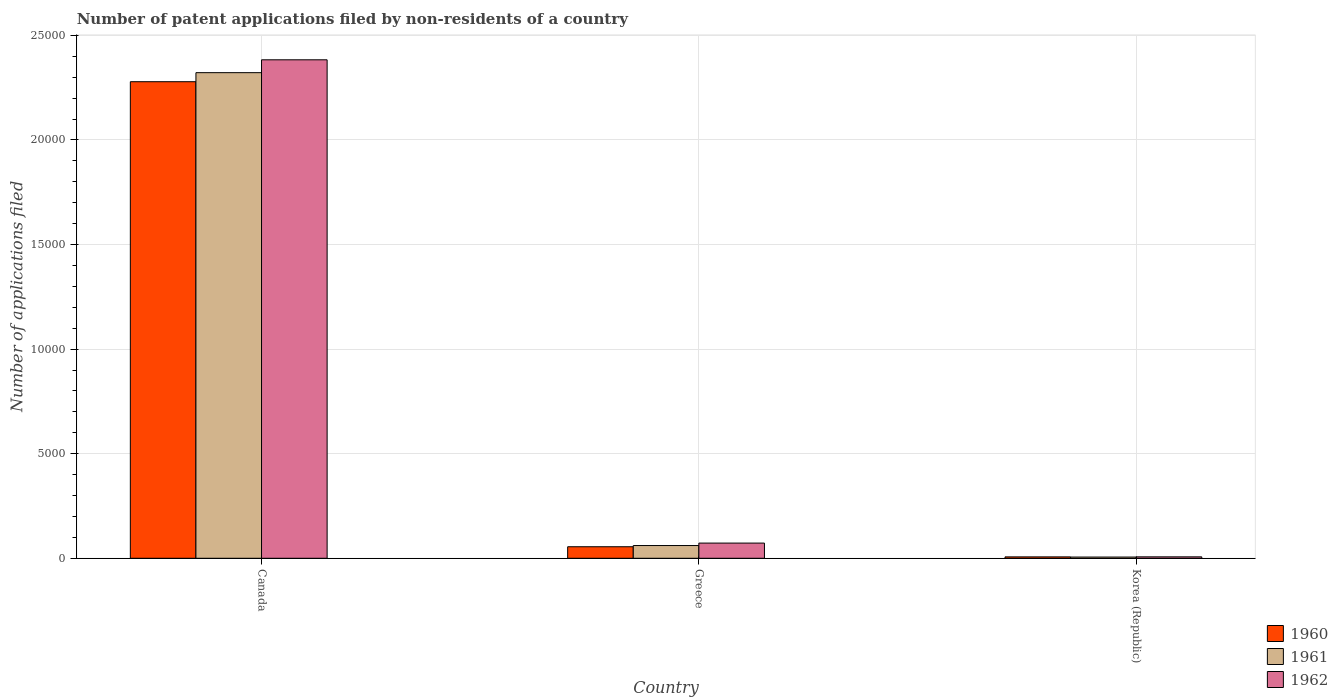Are the number of bars on each tick of the X-axis equal?
Provide a short and direct response. Yes. How many bars are there on the 1st tick from the left?
Your answer should be very brief. 3. What is the label of the 1st group of bars from the left?
Keep it short and to the point. Canada. What is the number of applications filed in 1960 in Canada?
Your response must be concise. 2.28e+04. Across all countries, what is the maximum number of applications filed in 1962?
Make the answer very short. 2.38e+04. In which country was the number of applications filed in 1961 maximum?
Give a very brief answer. Canada. In which country was the number of applications filed in 1961 minimum?
Ensure brevity in your answer.  Korea (Republic). What is the total number of applications filed in 1960 in the graph?
Provide a short and direct response. 2.34e+04. What is the difference between the number of applications filed in 1960 in Greece and that in Korea (Republic)?
Provide a succinct answer. 485. What is the difference between the number of applications filed in 1961 in Canada and the number of applications filed in 1962 in Greece?
Offer a terse response. 2.25e+04. What is the average number of applications filed in 1961 per country?
Your answer should be very brief. 7962. What is the difference between the number of applications filed of/in 1960 and number of applications filed of/in 1962 in Canada?
Your answer should be compact. -1048. In how many countries, is the number of applications filed in 1960 greater than 2000?
Provide a short and direct response. 1. What is the ratio of the number of applications filed in 1962 in Canada to that in Greece?
Your answer should be very brief. 32.83. Is the number of applications filed in 1962 in Canada less than that in Greece?
Offer a very short reply. No. Is the difference between the number of applications filed in 1960 in Greece and Korea (Republic) greater than the difference between the number of applications filed in 1962 in Greece and Korea (Republic)?
Your answer should be compact. No. What is the difference between the highest and the second highest number of applications filed in 1962?
Offer a very short reply. 2.38e+04. What is the difference between the highest and the lowest number of applications filed in 1960?
Offer a terse response. 2.27e+04. What does the 3rd bar from the right in Canada represents?
Keep it short and to the point. 1960. Are all the bars in the graph horizontal?
Provide a short and direct response. No. What is the difference between two consecutive major ticks on the Y-axis?
Your answer should be compact. 5000. Are the values on the major ticks of Y-axis written in scientific E-notation?
Offer a terse response. No. How many legend labels are there?
Provide a succinct answer. 3. What is the title of the graph?
Ensure brevity in your answer.  Number of patent applications filed by non-residents of a country. Does "1998" appear as one of the legend labels in the graph?
Your response must be concise. No. What is the label or title of the X-axis?
Ensure brevity in your answer.  Country. What is the label or title of the Y-axis?
Your answer should be very brief. Number of applications filed. What is the Number of applications filed of 1960 in Canada?
Your response must be concise. 2.28e+04. What is the Number of applications filed in 1961 in Canada?
Give a very brief answer. 2.32e+04. What is the Number of applications filed in 1962 in Canada?
Your answer should be compact. 2.38e+04. What is the Number of applications filed of 1960 in Greece?
Make the answer very short. 551. What is the Number of applications filed in 1961 in Greece?
Provide a short and direct response. 609. What is the Number of applications filed in 1962 in Greece?
Provide a short and direct response. 726. What is the Number of applications filed in 1960 in Korea (Republic)?
Keep it short and to the point. 66. What is the Number of applications filed in 1961 in Korea (Republic)?
Make the answer very short. 58. What is the Number of applications filed of 1962 in Korea (Republic)?
Your answer should be compact. 68. Across all countries, what is the maximum Number of applications filed of 1960?
Provide a short and direct response. 2.28e+04. Across all countries, what is the maximum Number of applications filed in 1961?
Your answer should be very brief. 2.32e+04. Across all countries, what is the maximum Number of applications filed in 1962?
Provide a succinct answer. 2.38e+04. Across all countries, what is the minimum Number of applications filed in 1960?
Keep it short and to the point. 66. Across all countries, what is the minimum Number of applications filed in 1962?
Make the answer very short. 68. What is the total Number of applications filed of 1960 in the graph?
Ensure brevity in your answer.  2.34e+04. What is the total Number of applications filed of 1961 in the graph?
Keep it short and to the point. 2.39e+04. What is the total Number of applications filed of 1962 in the graph?
Your answer should be compact. 2.46e+04. What is the difference between the Number of applications filed of 1960 in Canada and that in Greece?
Offer a very short reply. 2.22e+04. What is the difference between the Number of applications filed in 1961 in Canada and that in Greece?
Offer a very short reply. 2.26e+04. What is the difference between the Number of applications filed in 1962 in Canada and that in Greece?
Your response must be concise. 2.31e+04. What is the difference between the Number of applications filed of 1960 in Canada and that in Korea (Republic)?
Make the answer very short. 2.27e+04. What is the difference between the Number of applications filed of 1961 in Canada and that in Korea (Republic)?
Your answer should be very brief. 2.32e+04. What is the difference between the Number of applications filed of 1962 in Canada and that in Korea (Republic)?
Make the answer very short. 2.38e+04. What is the difference between the Number of applications filed in 1960 in Greece and that in Korea (Republic)?
Offer a very short reply. 485. What is the difference between the Number of applications filed in 1961 in Greece and that in Korea (Republic)?
Make the answer very short. 551. What is the difference between the Number of applications filed in 1962 in Greece and that in Korea (Republic)?
Ensure brevity in your answer.  658. What is the difference between the Number of applications filed of 1960 in Canada and the Number of applications filed of 1961 in Greece?
Offer a very short reply. 2.22e+04. What is the difference between the Number of applications filed in 1960 in Canada and the Number of applications filed in 1962 in Greece?
Make the answer very short. 2.21e+04. What is the difference between the Number of applications filed in 1961 in Canada and the Number of applications filed in 1962 in Greece?
Your answer should be compact. 2.25e+04. What is the difference between the Number of applications filed of 1960 in Canada and the Number of applications filed of 1961 in Korea (Republic)?
Provide a succinct answer. 2.27e+04. What is the difference between the Number of applications filed in 1960 in Canada and the Number of applications filed in 1962 in Korea (Republic)?
Offer a terse response. 2.27e+04. What is the difference between the Number of applications filed in 1961 in Canada and the Number of applications filed in 1962 in Korea (Republic)?
Your answer should be compact. 2.32e+04. What is the difference between the Number of applications filed in 1960 in Greece and the Number of applications filed in 1961 in Korea (Republic)?
Offer a terse response. 493. What is the difference between the Number of applications filed of 1960 in Greece and the Number of applications filed of 1962 in Korea (Republic)?
Your answer should be compact. 483. What is the difference between the Number of applications filed of 1961 in Greece and the Number of applications filed of 1962 in Korea (Republic)?
Make the answer very short. 541. What is the average Number of applications filed of 1960 per country?
Your answer should be very brief. 7801. What is the average Number of applications filed of 1961 per country?
Keep it short and to the point. 7962. What is the average Number of applications filed of 1962 per country?
Ensure brevity in your answer.  8209.33. What is the difference between the Number of applications filed in 1960 and Number of applications filed in 1961 in Canada?
Your response must be concise. -433. What is the difference between the Number of applications filed of 1960 and Number of applications filed of 1962 in Canada?
Offer a very short reply. -1048. What is the difference between the Number of applications filed of 1961 and Number of applications filed of 1962 in Canada?
Give a very brief answer. -615. What is the difference between the Number of applications filed in 1960 and Number of applications filed in 1961 in Greece?
Give a very brief answer. -58. What is the difference between the Number of applications filed of 1960 and Number of applications filed of 1962 in Greece?
Offer a very short reply. -175. What is the difference between the Number of applications filed in 1961 and Number of applications filed in 1962 in Greece?
Offer a terse response. -117. What is the difference between the Number of applications filed in 1960 and Number of applications filed in 1961 in Korea (Republic)?
Offer a terse response. 8. What is the difference between the Number of applications filed in 1961 and Number of applications filed in 1962 in Korea (Republic)?
Your answer should be compact. -10. What is the ratio of the Number of applications filed in 1960 in Canada to that in Greece?
Offer a very short reply. 41.35. What is the ratio of the Number of applications filed in 1961 in Canada to that in Greece?
Ensure brevity in your answer.  38.13. What is the ratio of the Number of applications filed of 1962 in Canada to that in Greece?
Give a very brief answer. 32.83. What is the ratio of the Number of applications filed of 1960 in Canada to that in Korea (Republic)?
Your answer should be very brief. 345.24. What is the ratio of the Number of applications filed in 1961 in Canada to that in Korea (Republic)?
Your answer should be compact. 400.33. What is the ratio of the Number of applications filed in 1962 in Canada to that in Korea (Republic)?
Provide a succinct answer. 350.5. What is the ratio of the Number of applications filed of 1960 in Greece to that in Korea (Republic)?
Provide a short and direct response. 8.35. What is the ratio of the Number of applications filed of 1962 in Greece to that in Korea (Republic)?
Offer a terse response. 10.68. What is the difference between the highest and the second highest Number of applications filed in 1960?
Ensure brevity in your answer.  2.22e+04. What is the difference between the highest and the second highest Number of applications filed of 1961?
Your answer should be compact. 2.26e+04. What is the difference between the highest and the second highest Number of applications filed in 1962?
Your response must be concise. 2.31e+04. What is the difference between the highest and the lowest Number of applications filed of 1960?
Your answer should be very brief. 2.27e+04. What is the difference between the highest and the lowest Number of applications filed in 1961?
Keep it short and to the point. 2.32e+04. What is the difference between the highest and the lowest Number of applications filed in 1962?
Your answer should be very brief. 2.38e+04. 